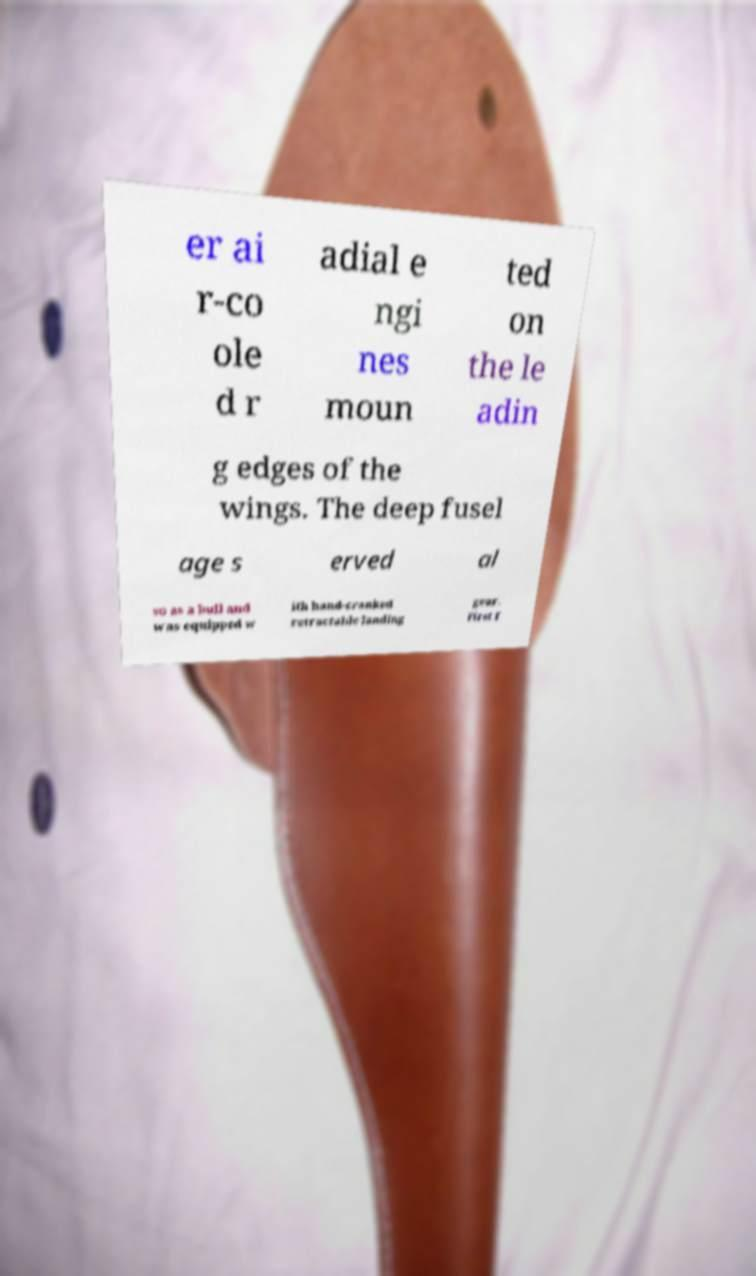For documentation purposes, I need the text within this image transcribed. Could you provide that? er ai r-co ole d r adial e ngi nes moun ted on the le adin g edges of the wings. The deep fusel age s erved al so as a hull and was equipped w ith hand-cranked retractable landing gear. First f 